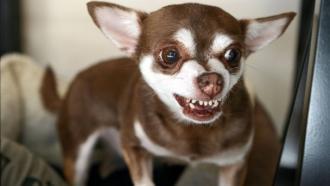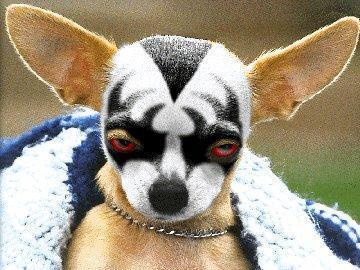The first image is the image on the left, the second image is the image on the right. For the images shown, is this caption "The left image features a fang-bearing chihuahua, and the right image features a chihuhua in costume-like get-up." true? Answer yes or no. Yes. The first image is the image on the left, the second image is the image on the right. Given the left and right images, does the statement "A chihuahua is wearing an article of clothing int he right image." hold true? Answer yes or no. Yes. 